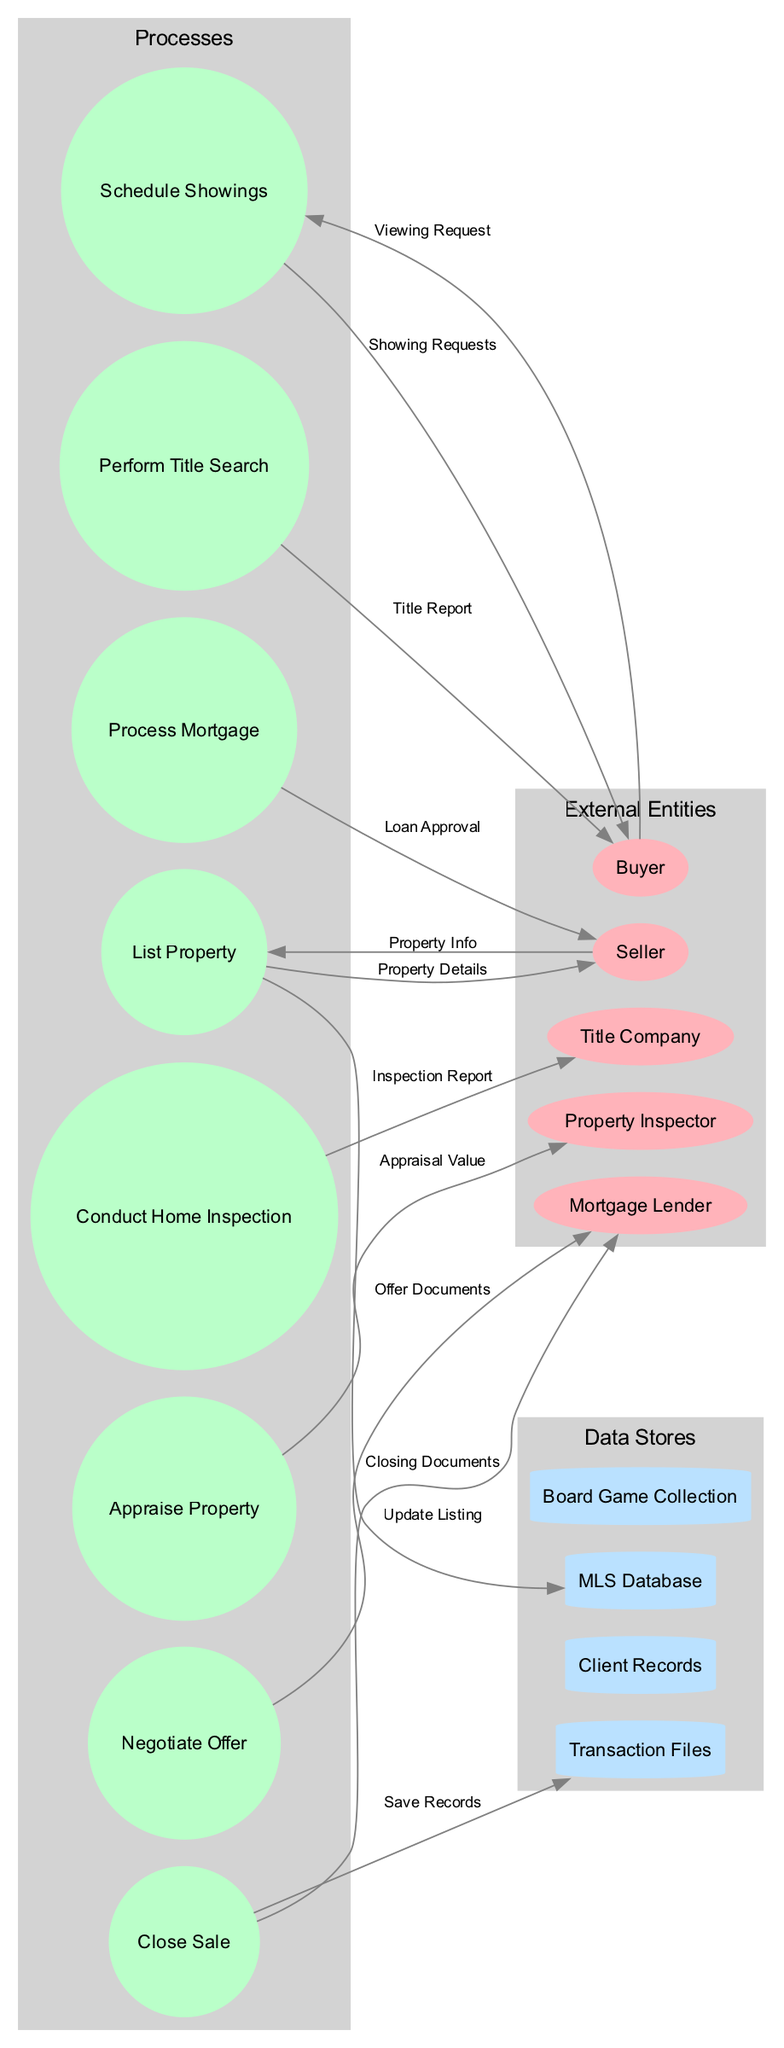What is the total number of external entities? The diagram lists five external entities which are Seller, Buyer, Mortgage Lender, Title Company, and Property Inspector. Counting these gives a total of 5 external entities.
Answer: 5 Which process is connected to the Buyer? The edge from Buyer points to the process Schedule Showings, indicating that the Buyer is involved in scheduling showings of the property.
Answer: Schedule Showings How many processes are shown in the diagram? There are eight distinct processes represented in the diagram: List Property, Schedule Showings, Negotiate Offer, Conduct Home Inspection, Appraise Property, Process Mortgage, Perform Title Search, and Close Sale. Counting these processes confirms there are 8.
Answer: 8 What data flow connects the Seller to the MLS Database? The data flow labeled "Update Listing" connects the List Property process to the MLS Database, involving input from the Seller to provide necessary information for the listing.
Answer: Update Listing Which data store is related to the Closing Documents? The Closing Documents flow leads to the Transaction Files data store, indicating that all closing records are stored there.
Answer: Transaction Files How many data flows originate from the process "Negotiate Offer"? The process "Negotiate Offer" has one outgoing flow, which is the Offer Documents flow connecting to Buyer, as shown in the diagram.
Answer: 1 Which external entity receives the Inspection Report? The Inspection Report flows from the Conduct Home Inspection process to the Buyer, indicating that the Buyer receives the report as part of the transaction process.
Answer: Buyer What is the relationship between the process "Close Sale" and "Transaction Files"? The Close Sale process flows into the Transaction Files, suggesting that this process results in saving relevant records of the transaction.
Answer: Save Records How many distinct types of data stores are depicted? There are four distinct data stores identified in the diagram: MLS Database, Client Records, Transaction Files, and Board Game Collection. Thus, the total number of data store types is 4.
Answer: 4 